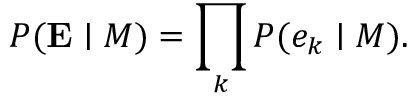<formula> <loc_0><loc_0><loc_500><loc_500>P ( E | M ) = \prod _ { k } { P ( e _ { k } | M ) } .</formula> 